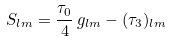Convert formula to latex. <formula><loc_0><loc_0><loc_500><loc_500>S _ { l m } = \frac { \tau _ { 0 } } { 4 } \, g _ { l m } - ( \tau _ { 3 } ) _ { l m }</formula> 